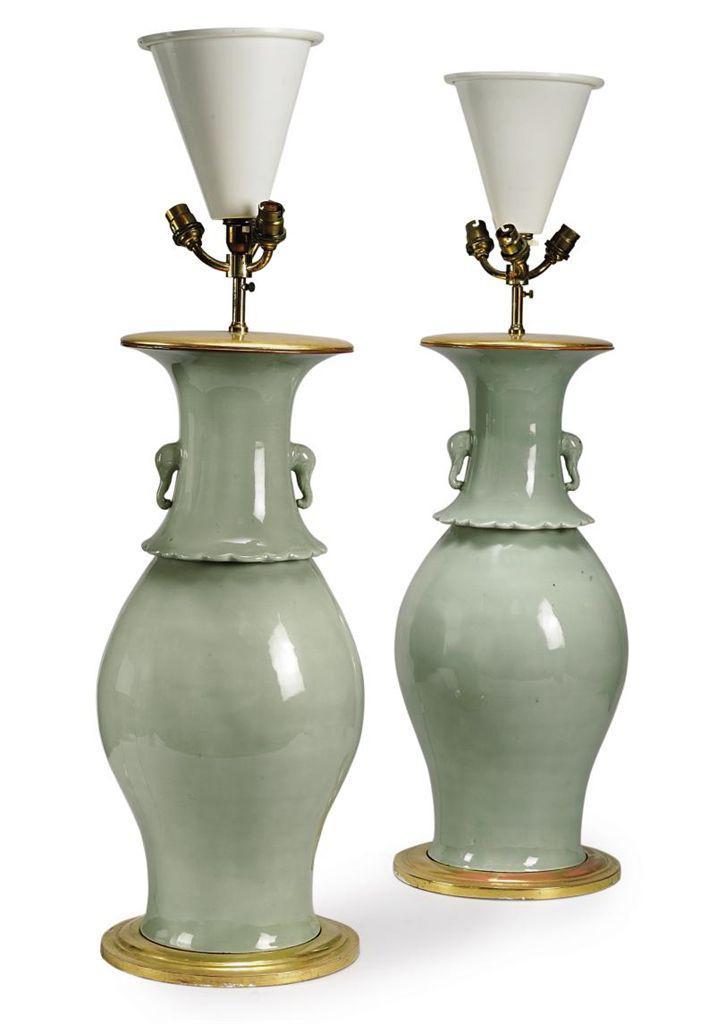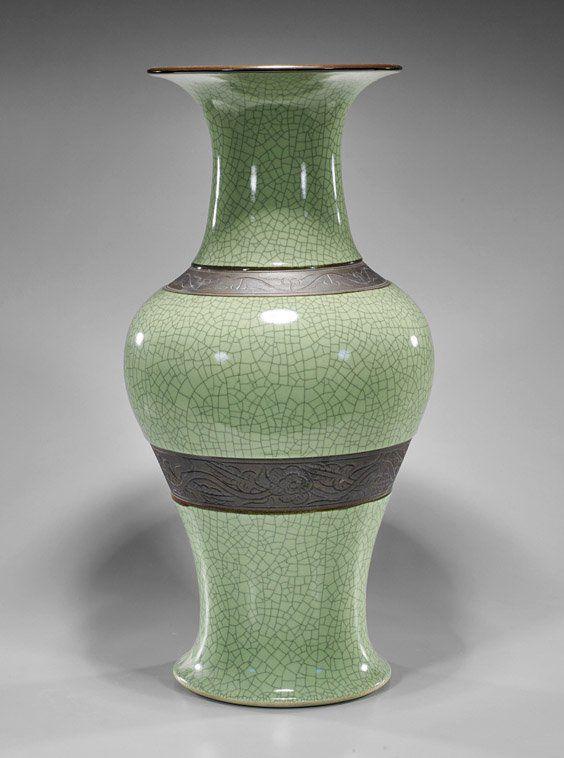The first image is the image on the left, the second image is the image on the right. For the images shown, is this caption "All ceramic objects are jade green, and at least one has a crackle finish, and at least one flares out at the top." true? Answer yes or no. Yes. The first image is the image on the left, the second image is the image on the right. For the images displayed, is the sentence "At least one of the lamps shown features a shiny brass base." factually correct? Answer yes or no. Yes. 